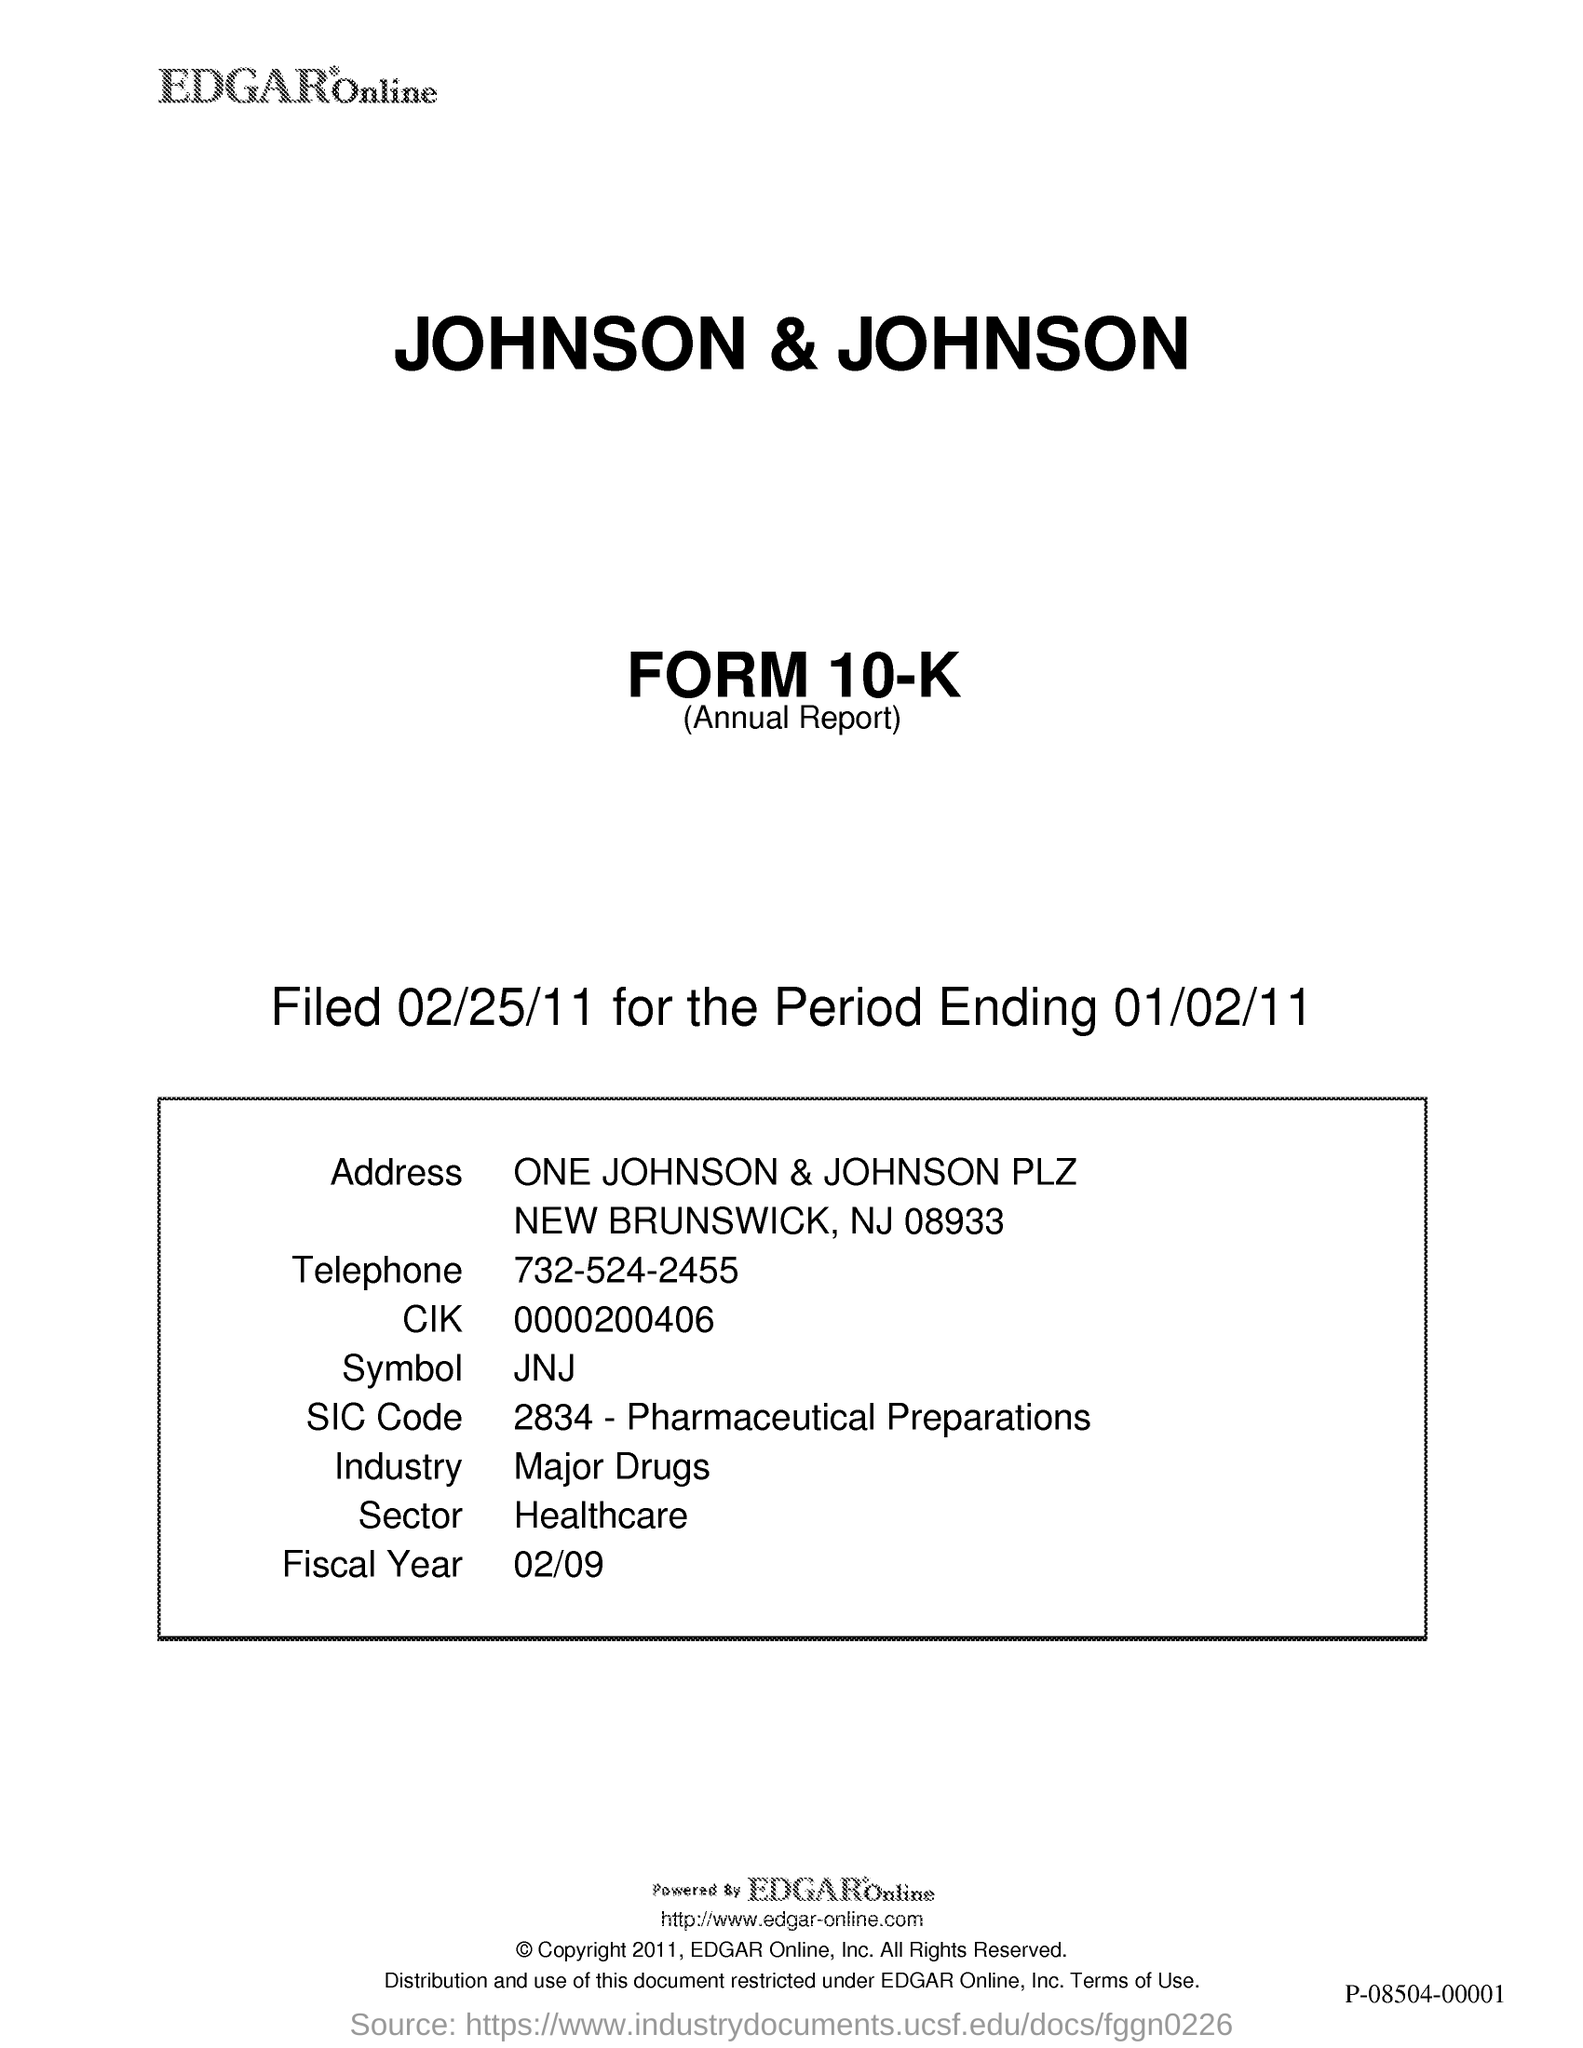What is the SIC Code given in the document?
Make the answer very short. 2834 - Pharmaceutical Preparations. What is the Telephone No given in this document?
Offer a very short reply. 732-524-2455. What is the industry type of the Johnson & Johnson company?
Your answer should be very brief. Major Drugs. What is the Fiscal Year given in the document?
Provide a succinct answer. 02/09. What is the symbol mentioned in the document?
Keep it short and to the point. JNJ. In which sector, the Johnson & Johnson company belongs to?
Offer a very short reply. Healthcare. 